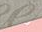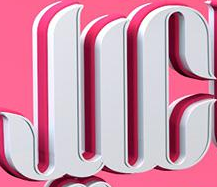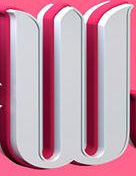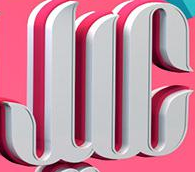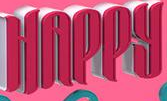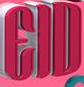Read the text from these images in sequence, separated by a semicolon. #; JIC; W; JIC; HAPPY; EID 